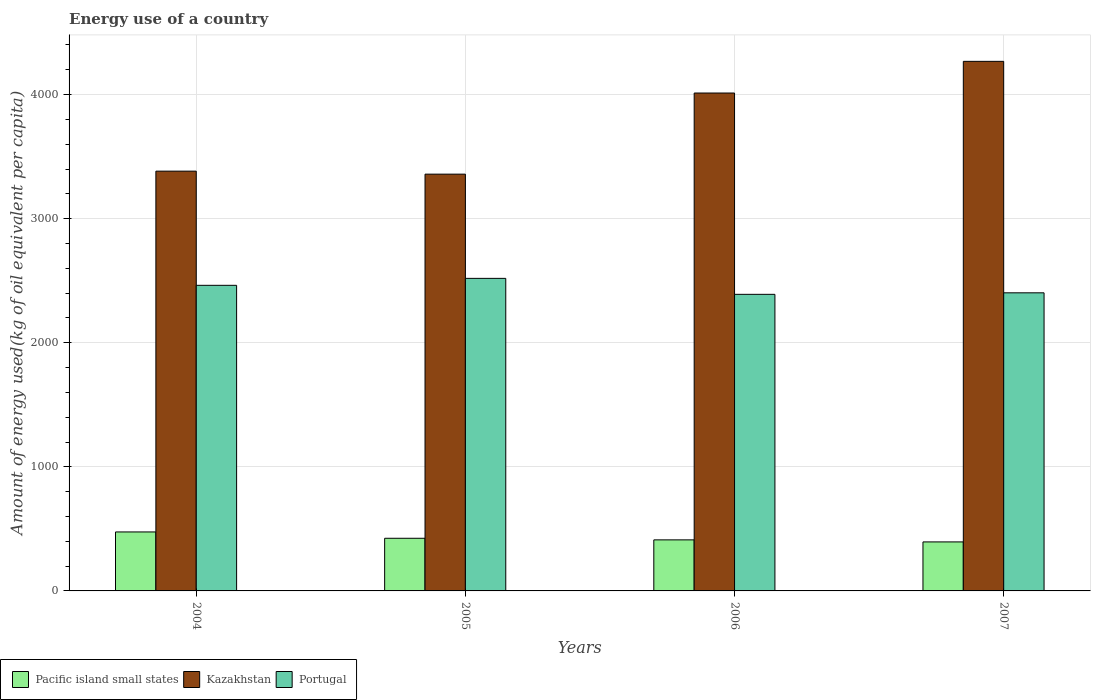How many groups of bars are there?
Ensure brevity in your answer.  4. Are the number of bars on each tick of the X-axis equal?
Your response must be concise. Yes. How many bars are there on the 3rd tick from the left?
Keep it short and to the point. 3. How many bars are there on the 2nd tick from the right?
Your answer should be compact. 3. What is the label of the 4th group of bars from the left?
Give a very brief answer. 2007. What is the amount of energy used in in Portugal in 2007?
Make the answer very short. 2402.48. Across all years, what is the maximum amount of energy used in in Pacific island small states?
Your answer should be very brief. 475.29. Across all years, what is the minimum amount of energy used in in Portugal?
Give a very brief answer. 2390.32. In which year was the amount of energy used in in Portugal minimum?
Make the answer very short. 2006. What is the total amount of energy used in in Portugal in the graph?
Make the answer very short. 9774.79. What is the difference between the amount of energy used in in Portugal in 2006 and that in 2007?
Your answer should be very brief. -12.15. What is the difference between the amount of energy used in in Pacific island small states in 2007 and the amount of energy used in in Portugal in 2005?
Offer a terse response. -2123.98. What is the average amount of energy used in in Portugal per year?
Keep it short and to the point. 2443.7. In the year 2006, what is the difference between the amount of energy used in in Kazakhstan and amount of energy used in in Portugal?
Your answer should be compact. 1622.46. What is the ratio of the amount of energy used in in Kazakhstan in 2005 to that in 2007?
Your answer should be compact. 0.79. What is the difference between the highest and the second highest amount of energy used in in Pacific island small states?
Your response must be concise. 51.03. What is the difference between the highest and the lowest amount of energy used in in Kazakhstan?
Your answer should be compact. 909.02. In how many years, is the amount of energy used in in Pacific island small states greater than the average amount of energy used in in Pacific island small states taken over all years?
Make the answer very short. 1. What does the 3rd bar from the left in 2007 represents?
Your answer should be compact. Portugal. What does the 2nd bar from the right in 2005 represents?
Give a very brief answer. Kazakhstan. Is it the case that in every year, the sum of the amount of energy used in in Portugal and amount of energy used in in Pacific island small states is greater than the amount of energy used in in Kazakhstan?
Your answer should be compact. No. What is the difference between two consecutive major ticks on the Y-axis?
Provide a short and direct response. 1000. Are the values on the major ticks of Y-axis written in scientific E-notation?
Your response must be concise. No. Does the graph contain any zero values?
Your answer should be compact. No. Does the graph contain grids?
Ensure brevity in your answer.  Yes. Where does the legend appear in the graph?
Provide a succinct answer. Bottom left. How many legend labels are there?
Keep it short and to the point. 3. What is the title of the graph?
Provide a short and direct response. Energy use of a country. What is the label or title of the Y-axis?
Provide a short and direct response. Amount of energy used(kg of oil equivalent per capita). What is the Amount of energy used(kg of oil equivalent per capita) of Pacific island small states in 2004?
Ensure brevity in your answer.  475.29. What is the Amount of energy used(kg of oil equivalent per capita) of Kazakhstan in 2004?
Offer a terse response. 3383.07. What is the Amount of energy used(kg of oil equivalent per capita) in Portugal in 2004?
Give a very brief answer. 2462.99. What is the Amount of energy used(kg of oil equivalent per capita) of Pacific island small states in 2005?
Your answer should be very brief. 424.27. What is the Amount of energy used(kg of oil equivalent per capita) of Kazakhstan in 2005?
Offer a very short reply. 3358.97. What is the Amount of energy used(kg of oil equivalent per capita) in Portugal in 2005?
Your response must be concise. 2519. What is the Amount of energy used(kg of oil equivalent per capita) of Pacific island small states in 2006?
Your answer should be very brief. 411.45. What is the Amount of energy used(kg of oil equivalent per capita) of Kazakhstan in 2006?
Make the answer very short. 4012.79. What is the Amount of energy used(kg of oil equivalent per capita) in Portugal in 2006?
Your answer should be compact. 2390.32. What is the Amount of energy used(kg of oil equivalent per capita) in Pacific island small states in 2007?
Give a very brief answer. 395.03. What is the Amount of energy used(kg of oil equivalent per capita) in Kazakhstan in 2007?
Your answer should be compact. 4267.99. What is the Amount of energy used(kg of oil equivalent per capita) in Portugal in 2007?
Provide a succinct answer. 2402.48. Across all years, what is the maximum Amount of energy used(kg of oil equivalent per capita) of Pacific island small states?
Your response must be concise. 475.29. Across all years, what is the maximum Amount of energy used(kg of oil equivalent per capita) of Kazakhstan?
Give a very brief answer. 4267.99. Across all years, what is the maximum Amount of energy used(kg of oil equivalent per capita) of Portugal?
Your answer should be compact. 2519. Across all years, what is the minimum Amount of energy used(kg of oil equivalent per capita) of Pacific island small states?
Keep it short and to the point. 395.03. Across all years, what is the minimum Amount of energy used(kg of oil equivalent per capita) in Kazakhstan?
Provide a short and direct response. 3358.97. Across all years, what is the minimum Amount of energy used(kg of oil equivalent per capita) of Portugal?
Your response must be concise. 2390.32. What is the total Amount of energy used(kg of oil equivalent per capita) of Pacific island small states in the graph?
Make the answer very short. 1706.03. What is the total Amount of energy used(kg of oil equivalent per capita) in Kazakhstan in the graph?
Provide a succinct answer. 1.50e+04. What is the total Amount of energy used(kg of oil equivalent per capita) in Portugal in the graph?
Your answer should be compact. 9774.79. What is the difference between the Amount of energy used(kg of oil equivalent per capita) of Pacific island small states in 2004 and that in 2005?
Offer a very short reply. 51.03. What is the difference between the Amount of energy used(kg of oil equivalent per capita) of Kazakhstan in 2004 and that in 2005?
Offer a very short reply. 24.1. What is the difference between the Amount of energy used(kg of oil equivalent per capita) in Portugal in 2004 and that in 2005?
Provide a succinct answer. -56.02. What is the difference between the Amount of energy used(kg of oil equivalent per capita) of Pacific island small states in 2004 and that in 2006?
Your answer should be very brief. 63.85. What is the difference between the Amount of energy used(kg of oil equivalent per capita) in Kazakhstan in 2004 and that in 2006?
Provide a short and direct response. -629.71. What is the difference between the Amount of energy used(kg of oil equivalent per capita) in Portugal in 2004 and that in 2006?
Ensure brevity in your answer.  72.66. What is the difference between the Amount of energy used(kg of oil equivalent per capita) of Pacific island small states in 2004 and that in 2007?
Ensure brevity in your answer.  80.27. What is the difference between the Amount of energy used(kg of oil equivalent per capita) of Kazakhstan in 2004 and that in 2007?
Offer a terse response. -884.92. What is the difference between the Amount of energy used(kg of oil equivalent per capita) of Portugal in 2004 and that in 2007?
Your response must be concise. 60.51. What is the difference between the Amount of energy used(kg of oil equivalent per capita) in Pacific island small states in 2005 and that in 2006?
Your response must be concise. 12.82. What is the difference between the Amount of energy used(kg of oil equivalent per capita) in Kazakhstan in 2005 and that in 2006?
Your response must be concise. -653.81. What is the difference between the Amount of energy used(kg of oil equivalent per capita) of Portugal in 2005 and that in 2006?
Provide a short and direct response. 128.68. What is the difference between the Amount of energy used(kg of oil equivalent per capita) of Pacific island small states in 2005 and that in 2007?
Give a very brief answer. 29.24. What is the difference between the Amount of energy used(kg of oil equivalent per capita) of Kazakhstan in 2005 and that in 2007?
Provide a succinct answer. -909.02. What is the difference between the Amount of energy used(kg of oil equivalent per capita) in Portugal in 2005 and that in 2007?
Offer a very short reply. 116.53. What is the difference between the Amount of energy used(kg of oil equivalent per capita) of Pacific island small states in 2006 and that in 2007?
Offer a very short reply. 16.42. What is the difference between the Amount of energy used(kg of oil equivalent per capita) of Kazakhstan in 2006 and that in 2007?
Make the answer very short. -255.21. What is the difference between the Amount of energy used(kg of oil equivalent per capita) of Portugal in 2006 and that in 2007?
Make the answer very short. -12.15. What is the difference between the Amount of energy used(kg of oil equivalent per capita) of Pacific island small states in 2004 and the Amount of energy used(kg of oil equivalent per capita) of Kazakhstan in 2005?
Give a very brief answer. -2883.68. What is the difference between the Amount of energy used(kg of oil equivalent per capita) in Pacific island small states in 2004 and the Amount of energy used(kg of oil equivalent per capita) in Portugal in 2005?
Make the answer very short. -2043.71. What is the difference between the Amount of energy used(kg of oil equivalent per capita) in Kazakhstan in 2004 and the Amount of energy used(kg of oil equivalent per capita) in Portugal in 2005?
Make the answer very short. 864.07. What is the difference between the Amount of energy used(kg of oil equivalent per capita) of Pacific island small states in 2004 and the Amount of energy used(kg of oil equivalent per capita) of Kazakhstan in 2006?
Provide a short and direct response. -3537.49. What is the difference between the Amount of energy used(kg of oil equivalent per capita) of Pacific island small states in 2004 and the Amount of energy used(kg of oil equivalent per capita) of Portugal in 2006?
Give a very brief answer. -1915.03. What is the difference between the Amount of energy used(kg of oil equivalent per capita) in Kazakhstan in 2004 and the Amount of energy used(kg of oil equivalent per capita) in Portugal in 2006?
Keep it short and to the point. 992.75. What is the difference between the Amount of energy used(kg of oil equivalent per capita) in Pacific island small states in 2004 and the Amount of energy used(kg of oil equivalent per capita) in Kazakhstan in 2007?
Offer a terse response. -3792.7. What is the difference between the Amount of energy used(kg of oil equivalent per capita) in Pacific island small states in 2004 and the Amount of energy used(kg of oil equivalent per capita) in Portugal in 2007?
Offer a very short reply. -1927.18. What is the difference between the Amount of energy used(kg of oil equivalent per capita) in Kazakhstan in 2004 and the Amount of energy used(kg of oil equivalent per capita) in Portugal in 2007?
Give a very brief answer. 980.6. What is the difference between the Amount of energy used(kg of oil equivalent per capita) in Pacific island small states in 2005 and the Amount of energy used(kg of oil equivalent per capita) in Kazakhstan in 2006?
Provide a short and direct response. -3588.52. What is the difference between the Amount of energy used(kg of oil equivalent per capita) of Pacific island small states in 2005 and the Amount of energy used(kg of oil equivalent per capita) of Portugal in 2006?
Ensure brevity in your answer.  -1966.06. What is the difference between the Amount of energy used(kg of oil equivalent per capita) in Kazakhstan in 2005 and the Amount of energy used(kg of oil equivalent per capita) in Portugal in 2006?
Your answer should be compact. 968.65. What is the difference between the Amount of energy used(kg of oil equivalent per capita) of Pacific island small states in 2005 and the Amount of energy used(kg of oil equivalent per capita) of Kazakhstan in 2007?
Ensure brevity in your answer.  -3843.73. What is the difference between the Amount of energy used(kg of oil equivalent per capita) in Pacific island small states in 2005 and the Amount of energy used(kg of oil equivalent per capita) in Portugal in 2007?
Make the answer very short. -1978.21. What is the difference between the Amount of energy used(kg of oil equivalent per capita) in Kazakhstan in 2005 and the Amount of energy used(kg of oil equivalent per capita) in Portugal in 2007?
Your answer should be very brief. 956.49. What is the difference between the Amount of energy used(kg of oil equivalent per capita) in Pacific island small states in 2006 and the Amount of energy used(kg of oil equivalent per capita) in Kazakhstan in 2007?
Provide a short and direct response. -3856.55. What is the difference between the Amount of energy used(kg of oil equivalent per capita) of Pacific island small states in 2006 and the Amount of energy used(kg of oil equivalent per capita) of Portugal in 2007?
Give a very brief answer. -1991.03. What is the difference between the Amount of energy used(kg of oil equivalent per capita) of Kazakhstan in 2006 and the Amount of energy used(kg of oil equivalent per capita) of Portugal in 2007?
Provide a short and direct response. 1610.31. What is the average Amount of energy used(kg of oil equivalent per capita) in Pacific island small states per year?
Provide a succinct answer. 426.51. What is the average Amount of energy used(kg of oil equivalent per capita) of Kazakhstan per year?
Make the answer very short. 3755.71. What is the average Amount of energy used(kg of oil equivalent per capita) in Portugal per year?
Provide a succinct answer. 2443.7. In the year 2004, what is the difference between the Amount of energy used(kg of oil equivalent per capita) in Pacific island small states and Amount of energy used(kg of oil equivalent per capita) in Kazakhstan?
Provide a short and direct response. -2907.78. In the year 2004, what is the difference between the Amount of energy used(kg of oil equivalent per capita) of Pacific island small states and Amount of energy used(kg of oil equivalent per capita) of Portugal?
Offer a terse response. -1987.69. In the year 2004, what is the difference between the Amount of energy used(kg of oil equivalent per capita) of Kazakhstan and Amount of energy used(kg of oil equivalent per capita) of Portugal?
Provide a succinct answer. 920.09. In the year 2005, what is the difference between the Amount of energy used(kg of oil equivalent per capita) in Pacific island small states and Amount of energy used(kg of oil equivalent per capita) in Kazakhstan?
Your answer should be compact. -2934.7. In the year 2005, what is the difference between the Amount of energy used(kg of oil equivalent per capita) in Pacific island small states and Amount of energy used(kg of oil equivalent per capita) in Portugal?
Offer a terse response. -2094.74. In the year 2005, what is the difference between the Amount of energy used(kg of oil equivalent per capita) of Kazakhstan and Amount of energy used(kg of oil equivalent per capita) of Portugal?
Your answer should be compact. 839.97. In the year 2006, what is the difference between the Amount of energy used(kg of oil equivalent per capita) of Pacific island small states and Amount of energy used(kg of oil equivalent per capita) of Kazakhstan?
Offer a terse response. -3601.34. In the year 2006, what is the difference between the Amount of energy used(kg of oil equivalent per capita) of Pacific island small states and Amount of energy used(kg of oil equivalent per capita) of Portugal?
Provide a short and direct response. -1978.88. In the year 2006, what is the difference between the Amount of energy used(kg of oil equivalent per capita) of Kazakhstan and Amount of energy used(kg of oil equivalent per capita) of Portugal?
Make the answer very short. 1622.46. In the year 2007, what is the difference between the Amount of energy used(kg of oil equivalent per capita) of Pacific island small states and Amount of energy used(kg of oil equivalent per capita) of Kazakhstan?
Make the answer very short. -3872.97. In the year 2007, what is the difference between the Amount of energy used(kg of oil equivalent per capita) of Pacific island small states and Amount of energy used(kg of oil equivalent per capita) of Portugal?
Provide a short and direct response. -2007.45. In the year 2007, what is the difference between the Amount of energy used(kg of oil equivalent per capita) of Kazakhstan and Amount of energy used(kg of oil equivalent per capita) of Portugal?
Your answer should be very brief. 1865.52. What is the ratio of the Amount of energy used(kg of oil equivalent per capita) in Pacific island small states in 2004 to that in 2005?
Offer a terse response. 1.12. What is the ratio of the Amount of energy used(kg of oil equivalent per capita) in Portugal in 2004 to that in 2005?
Make the answer very short. 0.98. What is the ratio of the Amount of energy used(kg of oil equivalent per capita) in Pacific island small states in 2004 to that in 2006?
Give a very brief answer. 1.16. What is the ratio of the Amount of energy used(kg of oil equivalent per capita) of Kazakhstan in 2004 to that in 2006?
Ensure brevity in your answer.  0.84. What is the ratio of the Amount of energy used(kg of oil equivalent per capita) in Portugal in 2004 to that in 2006?
Offer a terse response. 1.03. What is the ratio of the Amount of energy used(kg of oil equivalent per capita) of Pacific island small states in 2004 to that in 2007?
Provide a succinct answer. 1.2. What is the ratio of the Amount of energy used(kg of oil equivalent per capita) of Kazakhstan in 2004 to that in 2007?
Provide a short and direct response. 0.79. What is the ratio of the Amount of energy used(kg of oil equivalent per capita) of Portugal in 2004 to that in 2007?
Give a very brief answer. 1.03. What is the ratio of the Amount of energy used(kg of oil equivalent per capita) in Pacific island small states in 2005 to that in 2006?
Your answer should be compact. 1.03. What is the ratio of the Amount of energy used(kg of oil equivalent per capita) in Kazakhstan in 2005 to that in 2006?
Your answer should be compact. 0.84. What is the ratio of the Amount of energy used(kg of oil equivalent per capita) in Portugal in 2005 to that in 2006?
Give a very brief answer. 1.05. What is the ratio of the Amount of energy used(kg of oil equivalent per capita) in Pacific island small states in 2005 to that in 2007?
Provide a short and direct response. 1.07. What is the ratio of the Amount of energy used(kg of oil equivalent per capita) of Kazakhstan in 2005 to that in 2007?
Provide a short and direct response. 0.79. What is the ratio of the Amount of energy used(kg of oil equivalent per capita) of Portugal in 2005 to that in 2007?
Provide a short and direct response. 1.05. What is the ratio of the Amount of energy used(kg of oil equivalent per capita) in Pacific island small states in 2006 to that in 2007?
Provide a short and direct response. 1.04. What is the ratio of the Amount of energy used(kg of oil equivalent per capita) of Kazakhstan in 2006 to that in 2007?
Make the answer very short. 0.94. What is the ratio of the Amount of energy used(kg of oil equivalent per capita) of Portugal in 2006 to that in 2007?
Offer a terse response. 0.99. What is the difference between the highest and the second highest Amount of energy used(kg of oil equivalent per capita) of Pacific island small states?
Give a very brief answer. 51.03. What is the difference between the highest and the second highest Amount of energy used(kg of oil equivalent per capita) in Kazakhstan?
Offer a terse response. 255.21. What is the difference between the highest and the second highest Amount of energy used(kg of oil equivalent per capita) in Portugal?
Your answer should be very brief. 56.02. What is the difference between the highest and the lowest Amount of energy used(kg of oil equivalent per capita) of Pacific island small states?
Provide a succinct answer. 80.27. What is the difference between the highest and the lowest Amount of energy used(kg of oil equivalent per capita) of Kazakhstan?
Provide a succinct answer. 909.02. What is the difference between the highest and the lowest Amount of energy used(kg of oil equivalent per capita) of Portugal?
Ensure brevity in your answer.  128.68. 